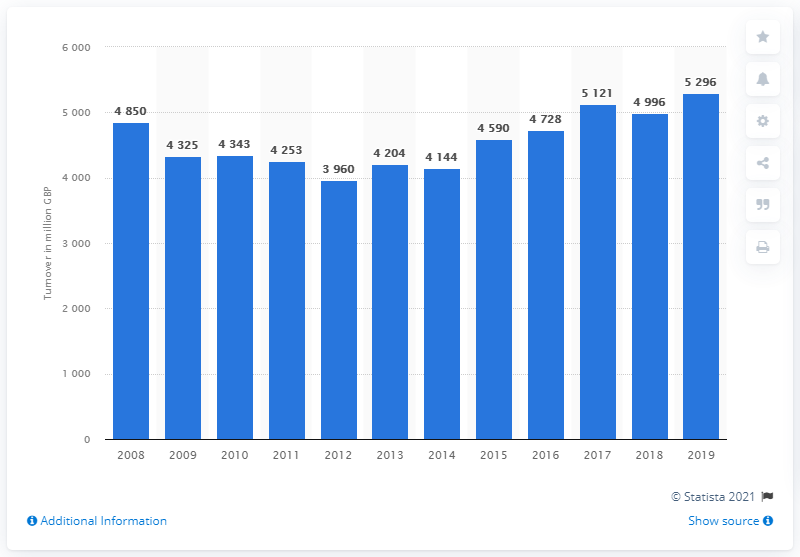List a handful of essential elements in this visual. In 2019, the medical and dental supply sector generated a total revenue of 5,296. 